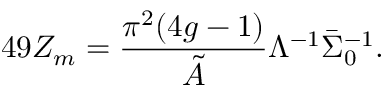Convert formula to latex. <formula><loc_0><loc_0><loc_500><loc_500>4 9 Z _ { m } = \frac { \pi ^ { 2 } ( 4 g - 1 ) } { \tilde { A } } \Lambda ^ { - 1 } \bar { \Sigma } _ { 0 } ^ { - 1 } .</formula> 